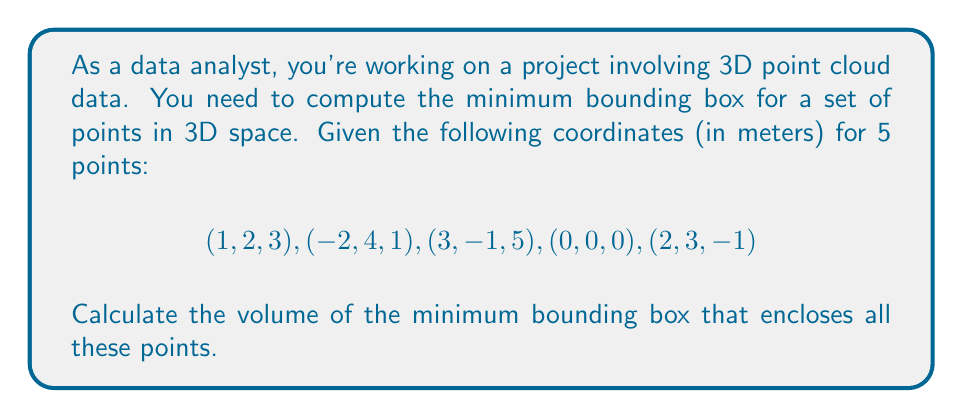Solve this math problem. To find the volume of the minimum bounding box for a 3D point cloud, we need to follow these steps:

1. Determine the minimum and maximum values for each dimension (x, y, and z):

   x: min = -2, max = 3
   y: min = -1, max = 4
   z: min = -1, max = 5

2. Calculate the dimensions of the bounding box:

   width (x) = max_x - min_x = 3 - (-2) = 5 m
   height (y) = max_y - min_y = 4 - (-1) = 5 m
   depth (z) = max_z - min_z = 5 - (-1) = 6 m

3. Compute the volume of the bounding box:

   $$V = width \times height \times depth$$
   $$V = 5 \times 5 \times 6 = 150 \text{ m}^3$$

Therefore, the volume of the minimum bounding box that encloses all the given points is 150 cubic meters.
Answer: 150 m³ 